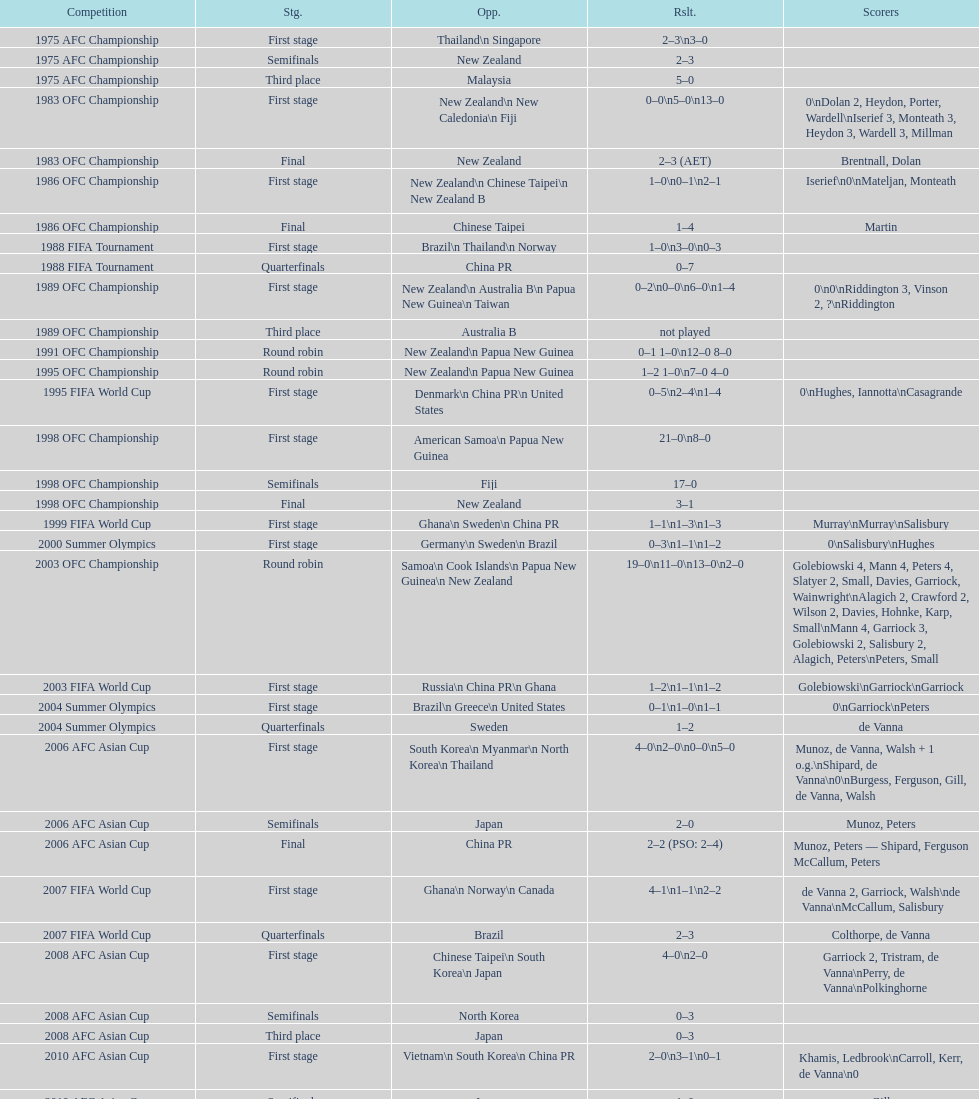How many points were scored in the final round of the 2012 summer olympics afc qualification? 12. 